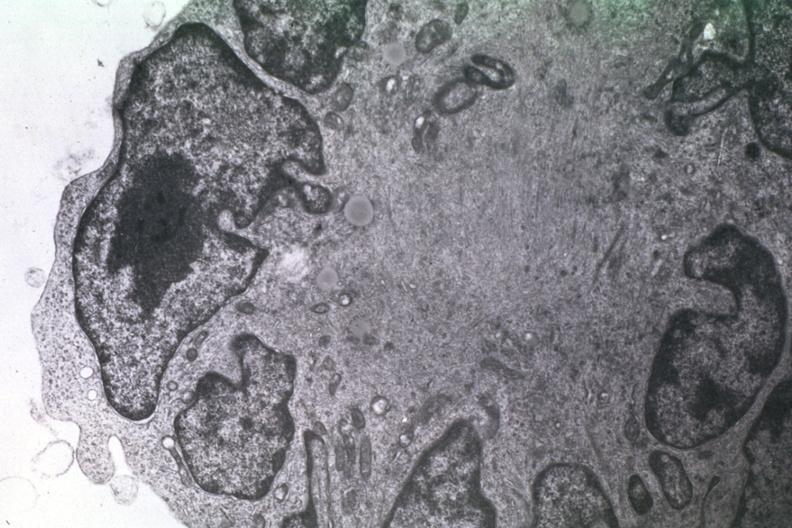s cat present?
Answer the question using a single word or phrase. No 